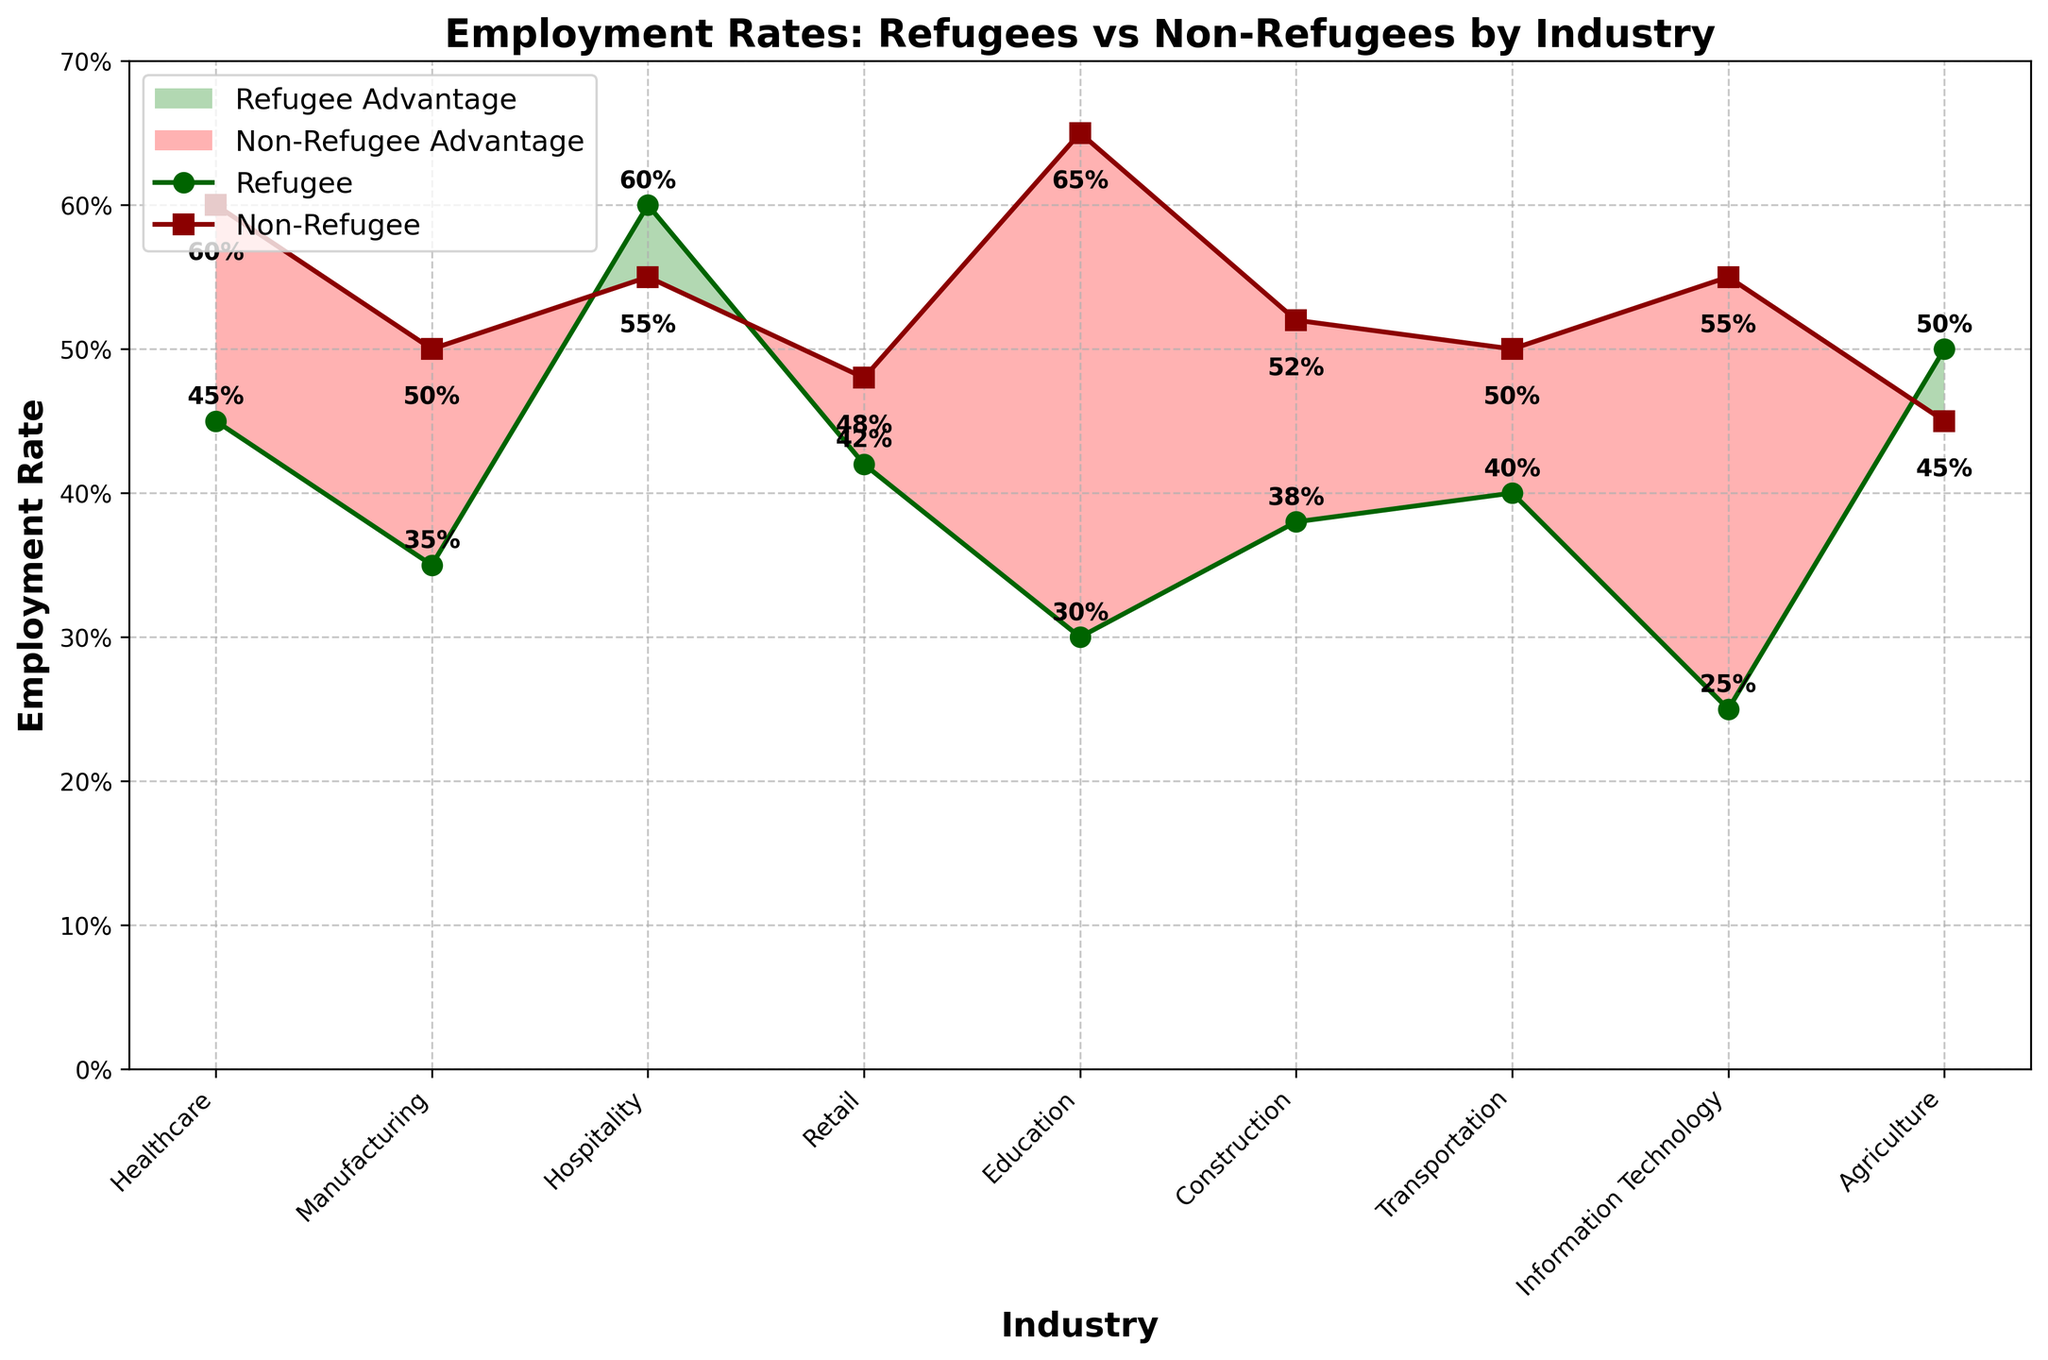What is the title of the chart? Look at the top of the chart where the title is displayed.
Answer: Employment Rates: Refugees vs Non-Refugees by Industry Which industry has the highest refugee employment rate? Look for the highest point on the refugee employment rate line (dark green).
Answer: Hospitality In which industry are the employment rates of refugees and non-refugees the same? Compare the points on the lines where refugee and non-refugee rates intersect or are closest.
Answer: Agriculture What is the difference in employment rates between refugees and non-refugees in the education sector? Find the employment rates for both refugees and non-refugees in Education and calculate the difference.
Answer: 0.35 Which industries show a refugee advantage in employment? Look for the shaded green areas where the refugee rate is higher than the non-refugee rate.
Answer: Hospitality and Agriculture Which industry has the largest gap in favor of non-refugees? Look for the largest red-shaded area. Identify and compare the highest difference points between the red area.
Answer: Education What is the average employment rate for refugees across all industries? Sum the refugee employment rates for all industries and divide by the number of industries: (0.45 + 0.35 + 0.60 + 0.42 + 0.30 + 0.38 + 0.40 + 0.25 + 0.50) / 9
Answer: 0.406 How do the employment rates in healthcare compare between refugees and non-refugees? Compare the points on the lines representing healthcare employment rates for both groups.
Answer: Non-refugees have a higher employment rate In which industry are non-refugees employed more than refugees by the smallest margin? Identify the smallest difference in favor of non-refugees by comparing the heights of the lines.
Answer: Information Technology What is the total number of industries represented in the chart? Count the number of industries listed on the x-axis.
Answer: 9 